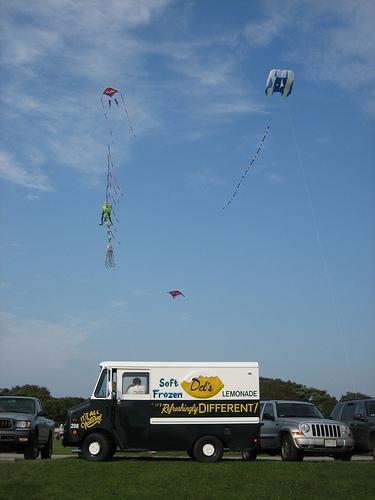How many kites are there?
Be succinct. 3. What type of truck is in the picture?
Concise answer only. Lemonade. Is there anything in the sky besides clouds?
Concise answer only. Kites. 